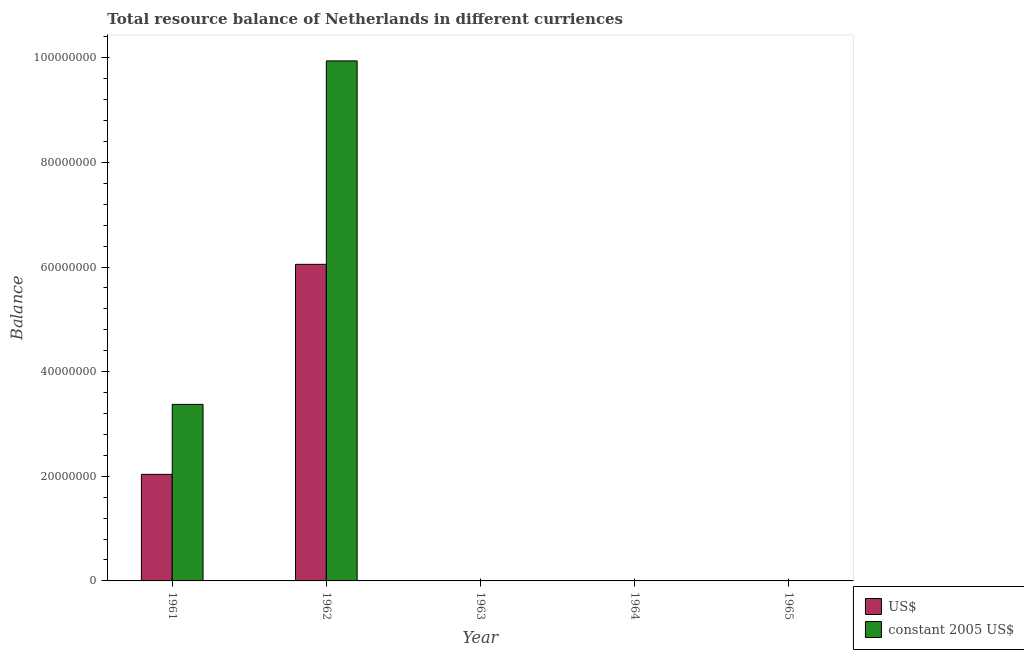Are the number of bars per tick equal to the number of legend labels?
Keep it short and to the point. No. Are the number of bars on each tick of the X-axis equal?
Make the answer very short. No. What is the label of the 3rd group of bars from the left?
Your response must be concise. 1963. In how many cases, is the number of bars for a given year not equal to the number of legend labels?
Your answer should be compact. 3. What is the resource balance in constant us$ in 1962?
Provide a short and direct response. 9.94e+07. Across all years, what is the maximum resource balance in constant us$?
Your answer should be very brief. 9.94e+07. What is the total resource balance in constant us$ in the graph?
Offer a very short reply. 1.33e+08. What is the difference between the resource balance in constant us$ in 1962 and the resource balance in us$ in 1965?
Keep it short and to the point. 9.94e+07. What is the average resource balance in us$ per year?
Make the answer very short. 1.62e+07. Is the difference between the resource balance in us$ in 1961 and 1962 greater than the difference between the resource balance in constant us$ in 1961 and 1962?
Your answer should be very brief. No. What is the difference between the highest and the lowest resource balance in us$?
Ensure brevity in your answer.  6.05e+07. In how many years, is the resource balance in us$ greater than the average resource balance in us$ taken over all years?
Your answer should be compact. 2. How many years are there in the graph?
Keep it short and to the point. 5. What is the difference between two consecutive major ticks on the Y-axis?
Your answer should be compact. 2.00e+07. Does the graph contain grids?
Offer a very short reply. No. How are the legend labels stacked?
Ensure brevity in your answer.  Vertical. What is the title of the graph?
Provide a short and direct response. Total resource balance of Netherlands in different curriences. Does "Male" appear as one of the legend labels in the graph?
Provide a succinct answer. No. What is the label or title of the Y-axis?
Give a very brief answer. Balance. What is the Balance in US$ in 1961?
Offer a very short reply. 2.04e+07. What is the Balance in constant 2005 US$ in 1961?
Provide a succinct answer. 3.37e+07. What is the Balance in US$ in 1962?
Offer a terse response. 6.05e+07. What is the Balance of constant 2005 US$ in 1962?
Make the answer very short. 9.94e+07. What is the Balance in constant 2005 US$ in 1963?
Ensure brevity in your answer.  0. Across all years, what is the maximum Balance in US$?
Make the answer very short. 6.05e+07. Across all years, what is the maximum Balance of constant 2005 US$?
Provide a succinct answer. 9.94e+07. What is the total Balance of US$ in the graph?
Make the answer very short. 8.09e+07. What is the total Balance in constant 2005 US$ in the graph?
Keep it short and to the point. 1.33e+08. What is the difference between the Balance of US$ in 1961 and that in 1962?
Keep it short and to the point. -4.01e+07. What is the difference between the Balance of constant 2005 US$ in 1961 and that in 1962?
Keep it short and to the point. -6.57e+07. What is the difference between the Balance of US$ in 1961 and the Balance of constant 2005 US$ in 1962?
Your answer should be compact. -7.90e+07. What is the average Balance of US$ per year?
Your answer should be very brief. 1.62e+07. What is the average Balance of constant 2005 US$ per year?
Keep it short and to the point. 2.66e+07. In the year 1961, what is the difference between the Balance in US$ and Balance in constant 2005 US$?
Give a very brief answer. -1.34e+07. In the year 1962, what is the difference between the Balance in US$ and Balance in constant 2005 US$?
Give a very brief answer. -3.89e+07. What is the ratio of the Balance in US$ in 1961 to that in 1962?
Keep it short and to the point. 0.34. What is the ratio of the Balance in constant 2005 US$ in 1961 to that in 1962?
Provide a succinct answer. 0.34. What is the difference between the highest and the lowest Balance of US$?
Your response must be concise. 6.05e+07. What is the difference between the highest and the lowest Balance of constant 2005 US$?
Your response must be concise. 9.94e+07. 